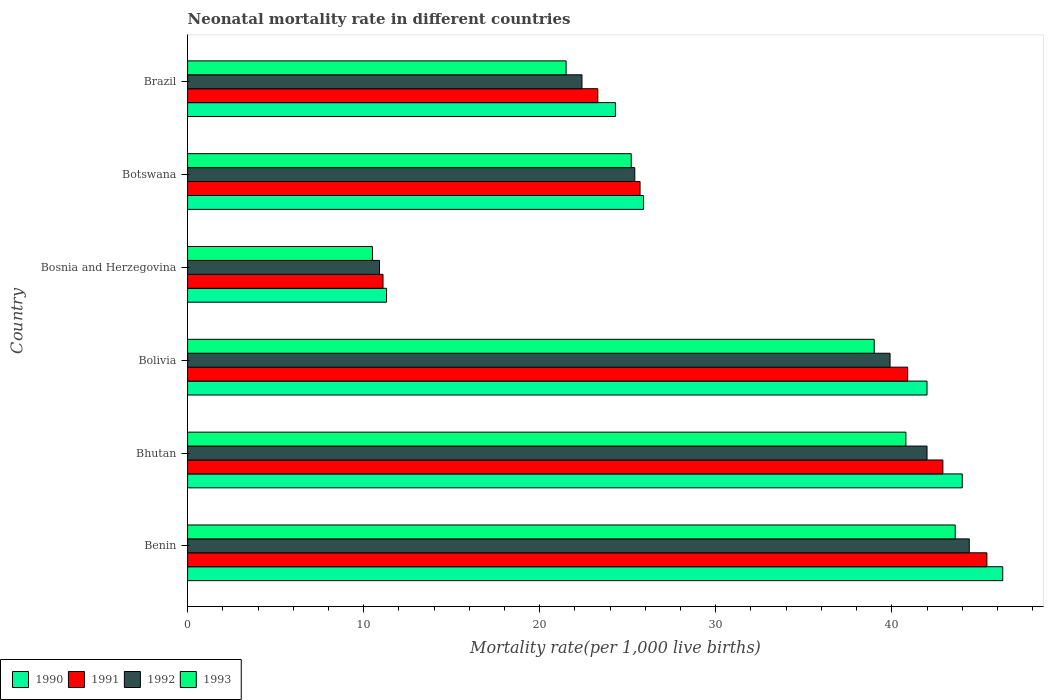How many groups of bars are there?
Your response must be concise. 6. Are the number of bars per tick equal to the number of legend labels?
Keep it short and to the point. Yes. Are the number of bars on each tick of the Y-axis equal?
Your response must be concise. Yes. How many bars are there on the 3rd tick from the top?
Make the answer very short. 4. What is the label of the 3rd group of bars from the top?
Provide a succinct answer. Bosnia and Herzegovina. In how many cases, is the number of bars for a given country not equal to the number of legend labels?
Provide a succinct answer. 0. What is the neonatal mortality rate in 1993 in Botswana?
Make the answer very short. 25.2. Across all countries, what is the maximum neonatal mortality rate in 1993?
Offer a very short reply. 43.6. Across all countries, what is the minimum neonatal mortality rate in 1992?
Provide a succinct answer. 10.9. In which country was the neonatal mortality rate in 1991 maximum?
Make the answer very short. Benin. In which country was the neonatal mortality rate in 1991 minimum?
Give a very brief answer. Bosnia and Herzegovina. What is the total neonatal mortality rate in 1990 in the graph?
Offer a very short reply. 193.8. What is the difference between the neonatal mortality rate in 1990 in Bolivia and that in Brazil?
Your answer should be very brief. 17.7. What is the average neonatal mortality rate in 1992 per country?
Ensure brevity in your answer.  30.83. What is the difference between the neonatal mortality rate in 1990 and neonatal mortality rate in 1991 in Botswana?
Provide a short and direct response. 0.2. In how many countries, is the neonatal mortality rate in 1993 greater than 6 ?
Give a very brief answer. 6. What is the ratio of the neonatal mortality rate in 1993 in Bhutan to that in Bolivia?
Your response must be concise. 1.05. Is the difference between the neonatal mortality rate in 1990 in Benin and Brazil greater than the difference between the neonatal mortality rate in 1991 in Benin and Brazil?
Your answer should be very brief. No. What is the difference between the highest and the lowest neonatal mortality rate in 1991?
Keep it short and to the point. 34.3. Is the sum of the neonatal mortality rate in 1992 in Benin and Brazil greater than the maximum neonatal mortality rate in 1991 across all countries?
Your answer should be very brief. Yes. What does the 3rd bar from the bottom in Bosnia and Herzegovina represents?
Your response must be concise. 1992. Is it the case that in every country, the sum of the neonatal mortality rate in 1992 and neonatal mortality rate in 1991 is greater than the neonatal mortality rate in 1993?
Make the answer very short. Yes. Are all the bars in the graph horizontal?
Give a very brief answer. Yes. What is the difference between two consecutive major ticks on the X-axis?
Give a very brief answer. 10. Does the graph contain grids?
Ensure brevity in your answer.  No. Where does the legend appear in the graph?
Offer a very short reply. Bottom left. How many legend labels are there?
Your answer should be compact. 4. How are the legend labels stacked?
Your answer should be very brief. Horizontal. What is the title of the graph?
Provide a succinct answer. Neonatal mortality rate in different countries. Does "1999" appear as one of the legend labels in the graph?
Your response must be concise. No. What is the label or title of the X-axis?
Ensure brevity in your answer.  Mortality rate(per 1,0 live births). What is the Mortality rate(per 1,000 live births) in 1990 in Benin?
Offer a terse response. 46.3. What is the Mortality rate(per 1,000 live births) of 1991 in Benin?
Offer a very short reply. 45.4. What is the Mortality rate(per 1,000 live births) in 1992 in Benin?
Offer a terse response. 44.4. What is the Mortality rate(per 1,000 live births) in 1993 in Benin?
Ensure brevity in your answer.  43.6. What is the Mortality rate(per 1,000 live births) in 1990 in Bhutan?
Provide a short and direct response. 44. What is the Mortality rate(per 1,000 live births) in 1991 in Bhutan?
Provide a short and direct response. 42.9. What is the Mortality rate(per 1,000 live births) in 1993 in Bhutan?
Offer a terse response. 40.8. What is the Mortality rate(per 1,000 live births) in 1990 in Bolivia?
Keep it short and to the point. 42. What is the Mortality rate(per 1,000 live births) in 1991 in Bolivia?
Provide a short and direct response. 40.9. What is the Mortality rate(per 1,000 live births) in 1992 in Bolivia?
Ensure brevity in your answer.  39.9. What is the Mortality rate(per 1,000 live births) in 1992 in Bosnia and Herzegovina?
Ensure brevity in your answer.  10.9. What is the Mortality rate(per 1,000 live births) of 1993 in Bosnia and Herzegovina?
Your answer should be compact. 10.5. What is the Mortality rate(per 1,000 live births) in 1990 in Botswana?
Provide a succinct answer. 25.9. What is the Mortality rate(per 1,000 live births) in 1991 in Botswana?
Ensure brevity in your answer.  25.7. What is the Mortality rate(per 1,000 live births) in 1992 in Botswana?
Offer a very short reply. 25.4. What is the Mortality rate(per 1,000 live births) of 1993 in Botswana?
Your answer should be compact. 25.2. What is the Mortality rate(per 1,000 live births) of 1990 in Brazil?
Offer a terse response. 24.3. What is the Mortality rate(per 1,000 live births) of 1991 in Brazil?
Give a very brief answer. 23.3. What is the Mortality rate(per 1,000 live births) of 1992 in Brazil?
Offer a very short reply. 22.4. Across all countries, what is the maximum Mortality rate(per 1,000 live births) in 1990?
Your answer should be compact. 46.3. Across all countries, what is the maximum Mortality rate(per 1,000 live births) in 1991?
Offer a very short reply. 45.4. Across all countries, what is the maximum Mortality rate(per 1,000 live births) of 1992?
Your answer should be very brief. 44.4. Across all countries, what is the maximum Mortality rate(per 1,000 live births) in 1993?
Your answer should be very brief. 43.6. Across all countries, what is the minimum Mortality rate(per 1,000 live births) of 1991?
Your answer should be compact. 11.1. What is the total Mortality rate(per 1,000 live births) of 1990 in the graph?
Your answer should be compact. 193.8. What is the total Mortality rate(per 1,000 live births) in 1991 in the graph?
Offer a terse response. 189.3. What is the total Mortality rate(per 1,000 live births) of 1992 in the graph?
Your answer should be compact. 185. What is the total Mortality rate(per 1,000 live births) in 1993 in the graph?
Your response must be concise. 180.6. What is the difference between the Mortality rate(per 1,000 live births) of 1993 in Benin and that in Bhutan?
Keep it short and to the point. 2.8. What is the difference between the Mortality rate(per 1,000 live births) in 1990 in Benin and that in Bolivia?
Make the answer very short. 4.3. What is the difference between the Mortality rate(per 1,000 live births) of 1991 in Benin and that in Bolivia?
Keep it short and to the point. 4.5. What is the difference between the Mortality rate(per 1,000 live births) of 1992 in Benin and that in Bolivia?
Provide a succinct answer. 4.5. What is the difference between the Mortality rate(per 1,000 live births) of 1990 in Benin and that in Bosnia and Herzegovina?
Make the answer very short. 35. What is the difference between the Mortality rate(per 1,000 live births) of 1991 in Benin and that in Bosnia and Herzegovina?
Provide a short and direct response. 34.3. What is the difference between the Mortality rate(per 1,000 live births) of 1992 in Benin and that in Bosnia and Herzegovina?
Keep it short and to the point. 33.5. What is the difference between the Mortality rate(per 1,000 live births) in 1993 in Benin and that in Bosnia and Herzegovina?
Your response must be concise. 33.1. What is the difference between the Mortality rate(per 1,000 live births) of 1990 in Benin and that in Botswana?
Your answer should be compact. 20.4. What is the difference between the Mortality rate(per 1,000 live births) of 1991 in Benin and that in Botswana?
Make the answer very short. 19.7. What is the difference between the Mortality rate(per 1,000 live births) in 1992 in Benin and that in Botswana?
Offer a terse response. 19. What is the difference between the Mortality rate(per 1,000 live births) in 1991 in Benin and that in Brazil?
Make the answer very short. 22.1. What is the difference between the Mortality rate(per 1,000 live births) of 1993 in Benin and that in Brazil?
Ensure brevity in your answer.  22.1. What is the difference between the Mortality rate(per 1,000 live births) of 1991 in Bhutan and that in Bolivia?
Offer a very short reply. 2. What is the difference between the Mortality rate(per 1,000 live births) in 1990 in Bhutan and that in Bosnia and Herzegovina?
Offer a terse response. 32.7. What is the difference between the Mortality rate(per 1,000 live births) in 1991 in Bhutan and that in Bosnia and Herzegovina?
Provide a short and direct response. 31.8. What is the difference between the Mortality rate(per 1,000 live births) in 1992 in Bhutan and that in Bosnia and Herzegovina?
Ensure brevity in your answer.  31.1. What is the difference between the Mortality rate(per 1,000 live births) of 1993 in Bhutan and that in Bosnia and Herzegovina?
Give a very brief answer. 30.3. What is the difference between the Mortality rate(per 1,000 live births) of 1991 in Bhutan and that in Botswana?
Your answer should be compact. 17.2. What is the difference between the Mortality rate(per 1,000 live births) of 1990 in Bhutan and that in Brazil?
Give a very brief answer. 19.7. What is the difference between the Mortality rate(per 1,000 live births) of 1991 in Bhutan and that in Brazil?
Your answer should be compact. 19.6. What is the difference between the Mortality rate(per 1,000 live births) of 1992 in Bhutan and that in Brazil?
Provide a short and direct response. 19.6. What is the difference between the Mortality rate(per 1,000 live births) of 1993 in Bhutan and that in Brazil?
Provide a short and direct response. 19.3. What is the difference between the Mortality rate(per 1,000 live births) of 1990 in Bolivia and that in Bosnia and Herzegovina?
Provide a short and direct response. 30.7. What is the difference between the Mortality rate(per 1,000 live births) of 1991 in Bolivia and that in Bosnia and Herzegovina?
Give a very brief answer. 29.8. What is the difference between the Mortality rate(per 1,000 live births) of 1992 in Bolivia and that in Bosnia and Herzegovina?
Provide a short and direct response. 29. What is the difference between the Mortality rate(per 1,000 live births) in 1992 in Bolivia and that in Botswana?
Give a very brief answer. 14.5. What is the difference between the Mortality rate(per 1,000 live births) of 1993 in Bolivia and that in Botswana?
Keep it short and to the point. 13.8. What is the difference between the Mortality rate(per 1,000 live births) in 1990 in Bolivia and that in Brazil?
Ensure brevity in your answer.  17.7. What is the difference between the Mortality rate(per 1,000 live births) of 1992 in Bolivia and that in Brazil?
Offer a very short reply. 17.5. What is the difference between the Mortality rate(per 1,000 live births) in 1990 in Bosnia and Herzegovina and that in Botswana?
Ensure brevity in your answer.  -14.6. What is the difference between the Mortality rate(per 1,000 live births) in 1991 in Bosnia and Herzegovina and that in Botswana?
Your answer should be compact. -14.6. What is the difference between the Mortality rate(per 1,000 live births) of 1993 in Bosnia and Herzegovina and that in Botswana?
Your answer should be very brief. -14.7. What is the difference between the Mortality rate(per 1,000 live births) in 1991 in Bosnia and Herzegovina and that in Brazil?
Provide a short and direct response. -12.2. What is the difference between the Mortality rate(per 1,000 live births) of 1992 in Bosnia and Herzegovina and that in Brazil?
Provide a short and direct response. -11.5. What is the difference between the Mortality rate(per 1,000 live births) in 1990 in Botswana and that in Brazil?
Ensure brevity in your answer.  1.6. What is the difference between the Mortality rate(per 1,000 live births) of 1991 in Botswana and that in Brazil?
Your answer should be compact. 2.4. What is the difference between the Mortality rate(per 1,000 live births) in 1992 in Botswana and that in Brazil?
Ensure brevity in your answer.  3. What is the difference between the Mortality rate(per 1,000 live births) of 1990 in Benin and the Mortality rate(per 1,000 live births) of 1991 in Bhutan?
Your answer should be very brief. 3.4. What is the difference between the Mortality rate(per 1,000 live births) in 1990 in Benin and the Mortality rate(per 1,000 live births) in 1992 in Bhutan?
Provide a short and direct response. 4.3. What is the difference between the Mortality rate(per 1,000 live births) of 1991 in Benin and the Mortality rate(per 1,000 live births) of 1992 in Bhutan?
Your answer should be compact. 3.4. What is the difference between the Mortality rate(per 1,000 live births) in 1992 in Benin and the Mortality rate(per 1,000 live births) in 1993 in Bhutan?
Your answer should be very brief. 3.6. What is the difference between the Mortality rate(per 1,000 live births) in 1990 in Benin and the Mortality rate(per 1,000 live births) in 1991 in Bolivia?
Give a very brief answer. 5.4. What is the difference between the Mortality rate(per 1,000 live births) of 1990 in Benin and the Mortality rate(per 1,000 live births) of 1992 in Bolivia?
Provide a succinct answer. 6.4. What is the difference between the Mortality rate(per 1,000 live births) of 1991 in Benin and the Mortality rate(per 1,000 live births) of 1993 in Bolivia?
Make the answer very short. 6.4. What is the difference between the Mortality rate(per 1,000 live births) of 1992 in Benin and the Mortality rate(per 1,000 live births) of 1993 in Bolivia?
Offer a terse response. 5.4. What is the difference between the Mortality rate(per 1,000 live births) of 1990 in Benin and the Mortality rate(per 1,000 live births) of 1991 in Bosnia and Herzegovina?
Offer a very short reply. 35.2. What is the difference between the Mortality rate(per 1,000 live births) of 1990 in Benin and the Mortality rate(per 1,000 live births) of 1992 in Bosnia and Herzegovina?
Give a very brief answer. 35.4. What is the difference between the Mortality rate(per 1,000 live births) of 1990 in Benin and the Mortality rate(per 1,000 live births) of 1993 in Bosnia and Herzegovina?
Give a very brief answer. 35.8. What is the difference between the Mortality rate(per 1,000 live births) in 1991 in Benin and the Mortality rate(per 1,000 live births) in 1992 in Bosnia and Herzegovina?
Keep it short and to the point. 34.5. What is the difference between the Mortality rate(per 1,000 live births) of 1991 in Benin and the Mortality rate(per 1,000 live births) of 1993 in Bosnia and Herzegovina?
Keep it short and to the point. 34.9. What is the difference between the Mortality rate(per 1,000 live births) of 1992 in Benin and the Mortality rate(per 1,000 live births) of 1993 in Bosnia and Herzegovina?
Keep it short and to the point. 33.9. What is the difference between the Mortality rate(per 1,000 live births) in 1990 in Benin and the Mortality rate(per 1,000 live births) in 1991 in Botswana?
Make the answer very short. 20.6. What is the difference between the Mortality rate(per 1,000 live births) of 1990 in Benin and the Mortality rate(per 1,000 live births) of 1992 in Botswana?
Give a very brief answer. 20.9. What is the difference between the Mortality rate(per 1,000 live births) of 1990 in Benin and the Mortality rate(per 1,000 live births) of 1993 in Botswana?
Keep it short and to the point. 21.1. What is the difference between the Mortality rate(per 1,000 live births) of 1991 in Benin and the Mortality rate(per 1,000 live births) of 1993 in Botswana?
Keep it short and to the point. 20.2. What is the difference between the Mortality rate(per 1,000 live births) in 1992 in Benin and the Mortality rate(per 1,000 live births) in 1993 in Botswana?
Provide a succinct answer. 19.2. What is the difference between the Mortality rate(per 1,000 live births) of 1990 in Benin and the Mortality rate(per 1,000 live births) of 1992 in Brazil?
Keep it short and to the point. 23.9. What is the difference between the Mortality rate(per 1,000 live births) of 1990 in Benin and the Mortality rate(per 1,000 live births) of 1993 in Brazil?
Your answer should be compact. 24.8. What is the difference between the Mortality rate(per 1,000 live births) of 1991 in Benin and the Mortality rate(per 1,000 live births) of 1993 in Brazil?
Provide a short and direct response. 23.9. What is the difference between the Mortality rate(per 1,000 live births) of 1992 in Benin and the Mortality rate(per 1,000 live births) of 1993 in Brazil?
Your answer should be compact. 22.9. What is the difference between the Mortality rate(per 1,000 live births) of 1990 in Bhutan and the Mortality rate(per 1,000 live births) of 1991 in Bolivia?
Offer a terse response. 3.1. What is the difference between the Mortality rate(per 1,000 live births) of 1990 in Bhutan and the Mortality rate(per 1,000 live births) of 1992 in Bolivia?
Keep it short and to the point. 4.1. What is the difference between the Mortality rate(per 1,000 live births) of 1991 in Bhutan and the Mortality rate(per 1,000 live births) of 1992 in Bolivia?
Offer a terse response. 3. What is the difference between the Mortality rate(per 1,000 live births) in 1991 in Bhutan and the Mortality rate(per 1,000 live births) in 1993 in Bolivia?
Offer a very short reply. 3.9. What is the difference between the Mortality rate(per 1,000 live births) in 1992 in Bhutan and the Mortality rate(per 1,000 live births) in 1993 in Bolivia?
Offer a terse response. 3. What is the difference between the Mortality rate(per 1,000 live births) of 1990 in Bhutan and the Mortality rate(per 1,000 live births) of 1991 in Bosnia and Herzegovina?
Keep it short and to the point. 32.9. What is the difference between the Mortality rate(per 1,000 live births) in 1990 in Bhutan and the Mortality rate(per 1,000 live births) in 1992 in Bosnia and Herzegovina?
Offer a very short reply. 33.1. What is the difference between the Mortality rate(per 1,000 live births) of 1990 in Bhutan and the Mortality rate(per 1,000 live births) of 1993 in Bosnia and Herzegovina?
Offer a terse response. 33.5. What is the difference between the Mortality rate(per 1,000 live births) of 1991 in Bhutan and the Mortality rate(per 1,000 live births) of 1992 in Bosnia and Herzegovina?
Offer a terse response. 32. What is the difference between the Mortality rate(per 1,000 live births) of 1991 in Bhutan and the Mortality rate(per 1,000 live births) of 1993 in Bosnia and Herzegovina?
Provide a short and direct response. 32.4. What is the difference between the Mortality rate(per 1,000 live births) of 1992 in Bhutan and the Mortality rate(per 1,000 live births) of 1993 in Bosnia and Herzegovina?
Provide a succinct answer. 31.5. What is the difference between the Mortality rate(per 1,000 live births) in 1991 in Bhutan and the Mortality rate(per 1,000 live births) in 1993 in Botswana?
Offer a terse response. 17.7. What is the difference between the Mortality rate(per 1,000 live births) in 1990 in Bhutan and the Mortality rate(per 1,000 live births) in 1991 in Brazil?
Ensure brevity in your answer.  20.7. What is the difference between the Mortality rate(per 1,000 live births) in 1990 in Bhutan and the Mortality rate(per 1,000 live births) in 1992 in Brazil?
Your response must be concise. 21.6. What is the difference between the Mortality rate(per 1,000 live births) in 1990 in Bhutan and the Mortality rate(per 1,000 live births) in 1993 in Brazil?
Ensure brevity in your answer.  22.5. What is the difference between the Mortality rate(per 1,000 live births) of 1991 in Bhutan and the Mortality rate(per 1,000 live births) of 1993 in Brazil?
Provide a short and direct response. 21.4. What is the difference between the Mortality rate(per 1,000 live births) in 1990 in Bolivia and the Mortality rate(per 1,000 live births) in 1991 in Bosnia and Herzegovina?
Your response must be concise. 30.9. What is the difference between the Mortality rate(per 1,000 live births) of 1990 in Bolivia and the Mortality rate(per 1,000 live births) of 1992 in Bosnia and Herzegovina?
Your answer should be very brief. 31.1. What is the difference between the Mortality rate(per 1,000 live births) in 1990 in Bolivia and the Mortality rate(per 1,000 live births) in 1993 in Bosnia and Herzegovina?
Offer a very short reply. 31.5. What is the difference between the Mortality rate(per 1,000 live births) of 1991 in Bolivia and the Mortality rate(per 1,000 live births) of 1993 in Bosnia and Herzegovina?
Your answer should be very brief. 30.4. What is the difference between the Mortality rate(per 1,000 live births) in 1992 in Bolivia and the Mortality rate(per 1,000 live births) in 1993 in Bosnia and Herzegovina?
Offer a very short reply. 29.4. What is the difference between the Mortality rate(per 1,000 live births) in 1990 in Bolivia and the Mortality rate(per 1,000 live births) in 1991 in Botswana?
Make the answer very short. 16.3. What is the difference between the Mortality rate(per 1,000 live births) of 1990 in Bolivia and the Mortality rate(per 1,000 live births) of 1992 in Botswana?
Offer a very short reply. 16.6. What is the difference between the Mortality rate(per 1,000 live births) in 1991 in Bolivia and the Mortality rate(per 1,000 live births) in 1992 in Botswana?
Your answer should be compact. 15.5. What is the difference between the Mortality rate(per 1,000 live births) of 1992 in Bolivia and the Mortality rate(per 1,000 live births) of 1993 in Botswana?
Offer a terse response. 14.7. What is the difference between the Mortality rate(per 1,000 live births) in 1990 in Bolivia and the Mortality rate(per 1,000 live births) in 1992 in Brazil?
Provide a short and direct response. 19.6. What is the difference between the Mortality rate(per 1,000 live births) of 1990 in Bolivia and the Mortality rate(per 1,000 live births) of 1993 in Brazil?
Provide a succinct answer. 20.5. What is the difference between the Mortality rate(per 1,000 live births) in 1991 in Bolivia and the Mortality rate(per 1,000 live births) in 1993 in Brazil?
Offer a very short reply. 19.4. What is the difference between the Mortality rate(per 1,000 live births) in 1990 in Bosnia and Herzegovina and the Mortality rate(per 1,000 live births) in 1991 in Botswana?
Provide a succinct answer. -14.4. What is the difference between the Mortality rate(per 1,000 live births) in 1990 in Bosnia and Herzegovina and the Mortality rate(per 1,000 live births) in 1992 in Botswana?
Offer a very short reply. -14.1. What is the difference between the Mortality rate(per 1,000 live births) of 1991 in Bosnia and Herzegovina and the Mortality rate(per 1,000 live births) of 1992 in Botswana?
Provide a short and direct response. -14.3. What is the difference between the Mortality rate(per 1,000 live births) of 1991 in Bosnia and Herzegovina and the Mortality rate(per 1,000 live births) of 1993 in Botswana?
Ensure brevity in your answer.  -14.1. What is the difference between the Mortality rate(per 1,000 live births) of 1992 in Bosnia and Herzegovina and the Mortality rate(per 1,000 live births) of 1993 in Botswana?
Ensure brevity in your answer.  -14.3. What is the difference between the Mortality rate(per 1,000 live births) in 1990 in Bosnia and Herzegovina and the Mortality rate(per 1,000 live births) in 1991 in Brazil?
Your response must be concise. -12. What is the difference between the Mortality rate(per 1,000 live births) of 1991 in Bosnia and Herzegovina and the Mortality rate(per 1,000 live births) of 1992 in Brazil?
Your answer should be very brief. -11.3. What is the difference between the Mortality rate(per 1,000 live births) of 1990 in Botswana and the Mortality rate(per 1,000 live births) of 1992 in Brazil?
Provide a short and direct response. 3.5. What is the difference between the Mortality rate(per 1,000 live births) of 1991 in Botswana and the Mortality rate(per 1,000 live births) of 1993 in Brazil?
Provide a short and direct response. 4.2. What is the difference between the Mortality rate(per 1,000 live births) in 1992 in Botswana and the Mortality rate(per 1,000 live births) in 1993 in Brazil?
Ensure brevity in your answer.  3.9. What is the average Mortality rate(per 1,000 live births) of 1990 per country?
Give a very brief answer. 32.3. What is the average Mortality rate(per 1,000 live births) in 1991 per country?
Provide a succinct answer. 31.55. What is the average Mortality rate(per 1,000 live births) of 1992 per country?
Make the answer very short. 30.83. What is the average Mortality rate(per 1,000 live births) in 1993 per country?
Make the answer very short. 30.1. What is the difference between the Mortality rate(per 1,000 live births) in 1990 and Mortality rate(per 1,000 live births) in 1991 in Benin?
Your answer should be compact. 0.9. What is the difference between the Mortality rate(per 1,000 live births) in 1990 and Mortality rate(per 1,000 live births) in 1992 in Benin?
Offer a terse response. 1.9. What is the difference between the Mortality rate(per 1,000 live births) of 1990 and Mortality rate(per 1,000 live births) of 1993 in Benin?
Give a very brief answer. 2.7. What is the difference between the Mortality rate(per 1,000 live births) in 1991 and Mortality rate(per 1,000 live births) in 1992 in Benin?
Ensure brevity in your answer.  1. What is the difference between the Mortality rate(per 1,000 live births) of 1991 and Mortality rate(per 1,000 live births) of 1993 in Benin?
Your answer should be compact. 1.8. What is the difference between the Mortality rate(per 1,000 live births) of 1992 and Mortality rate(per 1,000 live births) of 1993 in Bhutan?
Ensure brevity in your answer.  1.2. What is the difference between the Mortality rate(per 1,000 live births) of 1990 and Mortality rate(per 1,000 live births) of 1993 in Bolivia?
Your response must be concise. 3. What is the difference between the Mortality rate(per 1,000 live births) in 1991 and Mortality rate(per 1,000 live births) in 1993 in Bolivia?
Ensure brevity in your answer.  1.9. What is the difference between the Mortality rate(per 1,000 live births) in 1990 and Mortality rate(per 1,000 live births) in 1991 in Bosnia and Herzegovina?
Provide a short and direct response. 0.2. What is the difference between the Mortality rate(per 1,000 live births) in 1990 and Mortality rate(per 1,000 live births) in 1992 in Bosnia and Herzegovina?
Provide a short and direct response. 0.4. What is the difference between the Mortality rate(per 1,000 live births) of 1991 and Mortality rate(per 1,000 live births) of 1992 in Bosnia and Herzegovina?
Offer a very short reply. 0.2. What is the difference between the Mortality rate(per 1,000 live births) in 1991 and Mortality rate(per 1,000 live births) in 1993 in Bosnia and Herzegovina?
Provide a succinct answer. 0.6. What is the difference between the Mortality rate(per 1,000 live births) in 1990 and Mortality rate(per 1,000 live births) in 1991 in Botswana?
Offer a very short reply. 0.2. What is the difference between the Mortality rate(per 1,000 live births) in 1990 and Mortality rate(per 1,000 live births) in 1992 in Botswana?
Offer a very short reply. 0.5. What is the difference between the Mortality rate(per 1,000 live births) in 1990 and Mortality rate(per 1,000 live births) in 1993 in Botswana?
Offer a terse response. 0.7. What is the difference between the Mortality rate(per 1,000 live births) of 1991 and Mortality rate(per 1,000 live births) of 1992 in Botswana?
Make the answer very short. 0.3. What is the difference between the Mortality rate(per 1,000 live births) in 1991 and Mortality rate(per 1,000 live births) in 1993 in Botswana?
Your response must be concise. 0.5. What is the difference between the Mortality rate(per 1,000 live births) of 1992 and Mortality rate(per 1,000 live births) of 1993 in Botswana?
Your response must be concise. 0.2. What is the difference between the Mortality rate(per 1,000 live births) of 1992 and Mortality rate(per 1,000 live births) of 1993 in Brazil?
Keep it short and to the point. 0.9. What is the ratio of the Mortality rate(per 1,000 live births) in 1990 in Benin to that in Bhutan?
Your response must be concise. 1.05. What is the ratio of the Mortality rate(per 1,000 live births) in 1991 in Benin to that in Bhutan?
Give a very brief answer. 1.06. What is the ratio of the Mortality rate(per 1,000 live births) in 1992 in Benin to that in Bhutan?
Give a very brief answer. 1.06. What is the ratio of the Mortality rate(per 1,000 live births) in 1993 in Benin to that in Bhutan?
Keep it short and to the point. 1.07. What is the ratio of the Mortality rate(per 1,000 live births) in 1990 in Benin to that in Bolivia?
Offer a terse response. 1.1. What is the ratio of the Mortality rate(per 1,000 live births) of 1991 in Benin to that in Bolivia?
Your answer should be compact. 1.11. What is the ratio of the Mortality rate(per 1,000 live births) in 1992 in Benin to that in Bolivia?
Your answer should be very brief. 1.11. What is the ratio of the Mortality rate(per 1,000 live births) of 1993 in Benin to that in Bolivia?
Provide a short and direct response. 1.12. What is the ratio of the Mortality rate(per 1,000 live births) in 1990 in Benin to that in Bosnia and Herzegovina?
Provide a short and direct response. 4.1. What is the ratio of the Mortality rate(per 1,000 live births) in 1991 in Benin to that in Bosnia and Herzegovina?
Ensure brevity in your answer.  4.09. What is the ratio of the Mortality rate(per 1,000 live births) in 1992 in Benin to that in Bosnia and Herzegovina?
Provide a succinct answer. 4.07. What is the ratio of the Mortality rate(per 1,000 live births) of 1993 in Benin to that in Bosnia and Herzegovina?
Keep it short and to the point. 4.15. What is the ratio of the Mortality rate(per 1,000 live births) of 1990 in Benin to that in Botswana?
Ensure brevity in your answer.  1.79. What is the ratio of the Mortality rate(per 1,000 live births) of 1991 in Benin to that in Botswana?
Your answer should be very brief. 1.77. What is the ratio of the Mortality rate(per 1,000 live births) of 1992 in Benin to that in Botswana?
Offer a very short reply. 1.75. What is the ratio of the Mortality rate(per 1,000 live births) of 1993 in Benin to that in Botswana?
Offer a terse response. 1.73. What is the ratio of the Mortality rate(per 1,000 live births) of 1990 in Benin to that in Brazil?
Offer a terse response. 1.91. What is the ratio of the Mortality rate(per 1,000 live births) of 1991 in Benin to that in Brazil?
Keep it short and to the point. 1.95. What is the ratio of the Mortality rate(per 1,000 live births) in 1992 in Benin to that in Brazil?
Ensure brevity in your answer.  1.98. What is the ratio of the Mortality rate(per 1,000 live births) in 1993 in Benin to that in Brazil?
Keep it short and to the point. 2.03. What is the ratio of the Mortality rate(per 1,000 live births) of 1990 in Bhutan to that in Bolivia?
Give a very brief answer. 1.05. What is the ratio of the Mortality rate(per 1,000 live births) of 1991 in Bhutan to that in Bolivia?
Offer a very short reply. 1.05. What is the ratio of the Mortality rate(per 1,000 live births) in 1992 in Bhutan to that in Bolivia?
Offer a terse response. 1.05. What is the ratio of the Mortality rate(per 1,000 live births) of 1993 in Bhutan to that in Bolivia?
Provide a short and direct response. 1.05. What is the ratio of the Mortality rate(per 1,000 live births) in 1990 in Bhutan to that in Bosnia and Herzegovina?
Make the answer very short. 3.89. What is the ratio of the Mortality rate(per 1,000 live births) of 1991 in Bhutan to that in Bosnia and Herzegovina?
Give a very brief answer. 3.86. What is the ratio of the Mortality rate(per 1,000 live births) of 1992 in Bhutan to that in Bosnia and Herzegovina?
Provide a succinct answer. 3.85. What is the ratio of the Mortality rate(per 1,000 live births) of 1993 in Bhutan to that in Bosnia and Herzegovina?
Your answer should be very brief. 3.89. What is the ratio of the Mortality rate(per 1,000 live births) in 1990 in Bhutan to that in Botswana?
Your answer should be very brief. 1.7. What is the ratio of the Mortality rate(per 1,000 live births) of 1991 in Bhutan to that in Botswana?
Your answer should be very brief. 1.67. What is the ratio of the Mortality rate(per 1,000 live births) of 1992 in Bhutan to that in Botswana?
Give a very brief answer. 1.65. What is the ratio of the Mortality rate(per 1,000 live births) of 1993 in Bhutan to that in Botswana?
Offer a very short reply. 1.62. What is the ratio of the Mortality rate(per 1,000 live births) in 1990 in Bhutan to that in Brazil?
Your response must be concise. 1.81. What is the ratio of the Mortality rate(per 1,000 live births) in 1991 in Bhutan to that in Brazil?
Your response must be concise. 1.84. What is the ratio of the Mortality rate(per 1,000 live births) in 1992 in Bhutan to that in Brazil?
Keep it short and to the point. 1.88. What is the ratio of the Mortality rate(per 1,000 live births) of 1993 in Bhutan to that in Brazil?
Ensure brevity in your answer.  1.9. What is the ratio of the Mortality rate(per 1,000 live births) of 1990 in Bolivia to that in Bosnia and Herzegovina?
Ensure brevity in your answer.  3.72. What is the ratio of the Mortality rate(per 1,000 live births) in 1991 in Bolivia to that in Bosnia and Herzegovina?
Provide a succinct answer. 3.68. What is the ratio of the Mortality rate(per 1,000 live births) of 1992 in Bolivia to that in Bosnia and Herzegovina?
Offer a very short reply. 3.66. What is the ratio of the Mortality rate(per 1,000 live births) of 1993 in Bolivia to that in Bosnia and Herzegovina?
Your response must be concise. 3.71. What is the ratio of the Mortality rate(per 1,000 live births) in 1990 in Bolivia to that in Botswana?
Make the answer very short. 1.62. What is the ratio of the Mortality rate(per 1,000 live births) in 1991 in Bolivia to that in Botswana?
Make the answer very short. 1.59. What is the ratio of the Mortality rate(per 1,000 live births) of 1992 in Bolivia to that in Botswana?
Ensure brevity in your answer.  1.57. What is the ratio of the Mortality rate(per 1,000 live births) in 1993 in Bolivia to that in Botswana?
Your response must be concise. 1.55. What is the ratio of the Mortality rate(per 1,000 live births) in 1990 in Bolivia to that in Brazil?
Ensure brevity in your answer.  1.73. What is the ratio of the Mortality rate(per 1,000 live births) in 1991 in Bolivia to that in Brazil?
Your answer should be very brief. 1.76. What is the ratio of the Mortality rate(per 1,000 live births) in 1992 in Bolivia to that in Brazil?
Your response must be concise. 1.78. What is the ratio of the Mortality rate(per 1,000 live births) in 1993 in Bolivia to that in Brazil?
Provide a succinct answer. 1.81. What is the ratio of the Mortality rate(per 1,000 live births) in 1990 in Bosnia and Herzegovina to that in Botswana?
Provide a short and direct response. 0.44. What is the ratio of the Mortality rate(per 1,000 live births) of 1991 in Bosnia and Herzegovina to that in Botswana?
Make the answer very short. 0.43. What is the ratio of the Mortality rate(per 1,000 live births) of 1992 in Bosnia and Herzegovina to that in Botswana?
Make the answer very short. 0.43. What is the ratio of the Mortality rate(per 1,000 live births) of 1993 in Bosnia and Herzegovina to that in Botswana?
Provide a short and direct response. 0.42. What is the ratio of the Mortality rate(per 1,000 live births) in 1990 in Bosnia and Herzegovina to that in Brazil?
Offer a very short reply. 0.47. What is the ratio of the Mortality rate(per 1,000 live births) of 1991 in Bosnia and Herzegovina to that in Brazil?
Make the answer very short. 0.48. What is the ratio of the Mortality rate(per 1,000 live births) of 1992 in Bosnia and Herzegovina to that in Brazil?
Your answer should be compact. 0.49. What is the ratio of the Mortality rate(per 1,000 live births) of 1993 in Bosnia and Herzegovina to that in Brazil?
Offer a terse response. 0.49. What is the ratio of the Mortality rate(per 1,000 live births) of 1990 in Botswana to that in Brazil?
Your answer should be very brief. 1.07. What is the ratio of the Mortality rate(per 1,000 live births) of 1991 in Botswana to that in Brazil?
Make the answer very short. 1.1. What is the ratio of the Mortality rate(per 1,000 live births) of 1992 in Botswana to that in Brazil?
Offer a very short reply. 1.13. What is the ratio of the Mortality rate(per 1,000 live births) of 1993 in Botswana to that in Brazil?
Offer a terse response. 1.17. What is the difference between the highest and the second highest Mortality rate(per 1,000 live births) in 1992?
Offer a very short reply. 2.4. What is the difference between the highest and the lowest Mortality rate(per 1,000 live births) in 1991?
Your answer should be very brief. 34.3. What is the difference between the highest and the lowest Mortality rate(per 1,000 live births) of 1992?
Offer a terse response. 33.5. What is the difference between the highest and the lowest Mortality rate(per 1,000 live births) of 1993?
Make the answer very short. 33.1. 